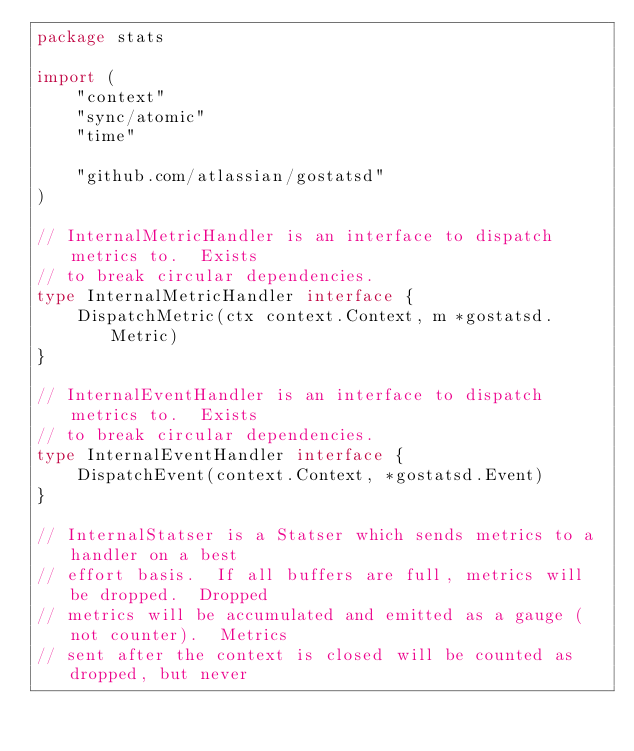Convert code to text. <code><loc_0><loc_0><loc_500><loc_500><_Go_>package stats

import (
	"context"
	"sync/atomic"
	"time"

	"github.com/atlassian/gostatsd"
)

// InternalMetricHandler is an interface to dispatch metrics to.  Exists
// to break circular dependencies.
type InternalMetricHandler interface {
	DispatchMetric(ctx context.Context, m *gostatsd.Metric)
}

// InternalEventHandler is an interface to dispatch metrics to.  Exists
// to break circular dependencies.
type InternalEventHandler interface {
	DispatchEvent(context.Context, *gostatsd.Event)
}

// InternalStatser is a Statser which sends metrics to a handler on a best
// effort basis.  If all buffers are full, metrics will be dropped.  Dropped
// metrics will be accumulated and emitted as a gauge (not counter).  Metrics
// sent after the context is closed will be counted as dropped, but never</code> 